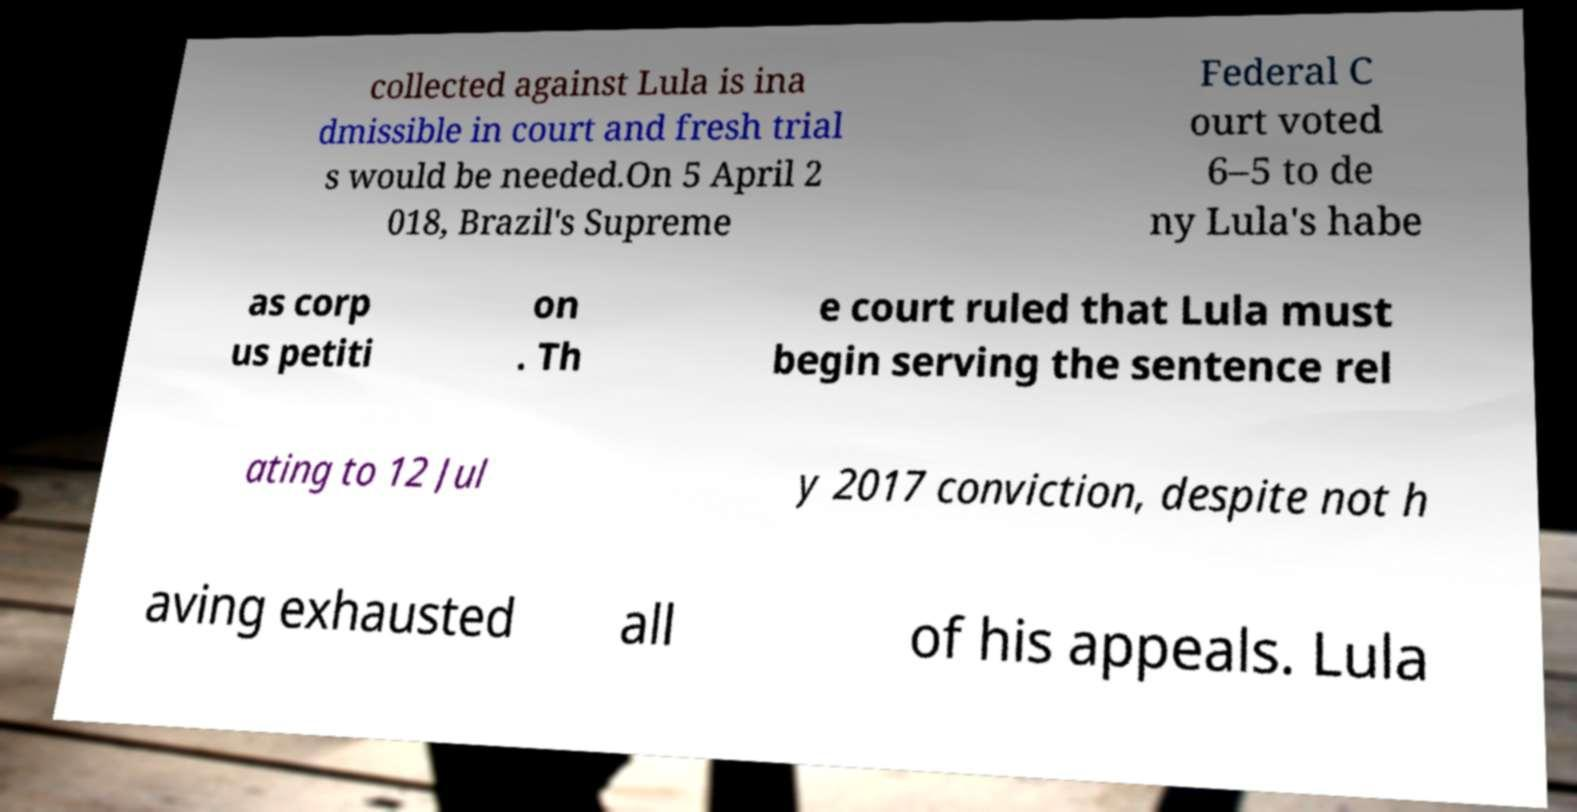Can you accurately transcribe the text from the provided image for me? collected against Lula is ina dmissible in court and fresh trial s would be needed.On 5 April 2 018, Brazil's Supreme Federal C ourt voted 6–5 to de ny Lula's habe as corp us petiti on . Th e court ruled that Lula must begin serving the sentence rel ating to 12 Jul y 2017 conviction, despite not h aving exhausted all of his appeals. Lula 